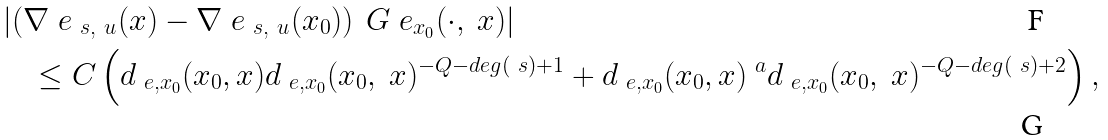<formula> <loc_0><loc_0><loc_500><loc_500>& \left | \left ( \nabla ^ { \ } e _ { \ s , \ u } ( x ) - \nabla ^ { \ } e _ { \ s , \ u } ( x _ { 0 } ) \right ) \ G ^ { \ } e _ { x _ { 0 } } ( \cdot , \ x ) \right | \\ & \quad \leq C \left ( d _ { \ e , x _ { 0 } } ( x _ { 0 } , x ) d _ { \ e , x _ { 0 } } ( x _ { 0 } , \ x ) ^ { - Q - d e g ( \ s ) + 1 } + d _ { \ e , x _ { 0 } } ( x _ { 0 } , x ) ^ { \ a } d _ { \ e , x _ { 0 } } ( x _ { 0 } , \ x ) ^ { - Q - d e g ( \ s ) + 2 } \right ) ,</formula> 